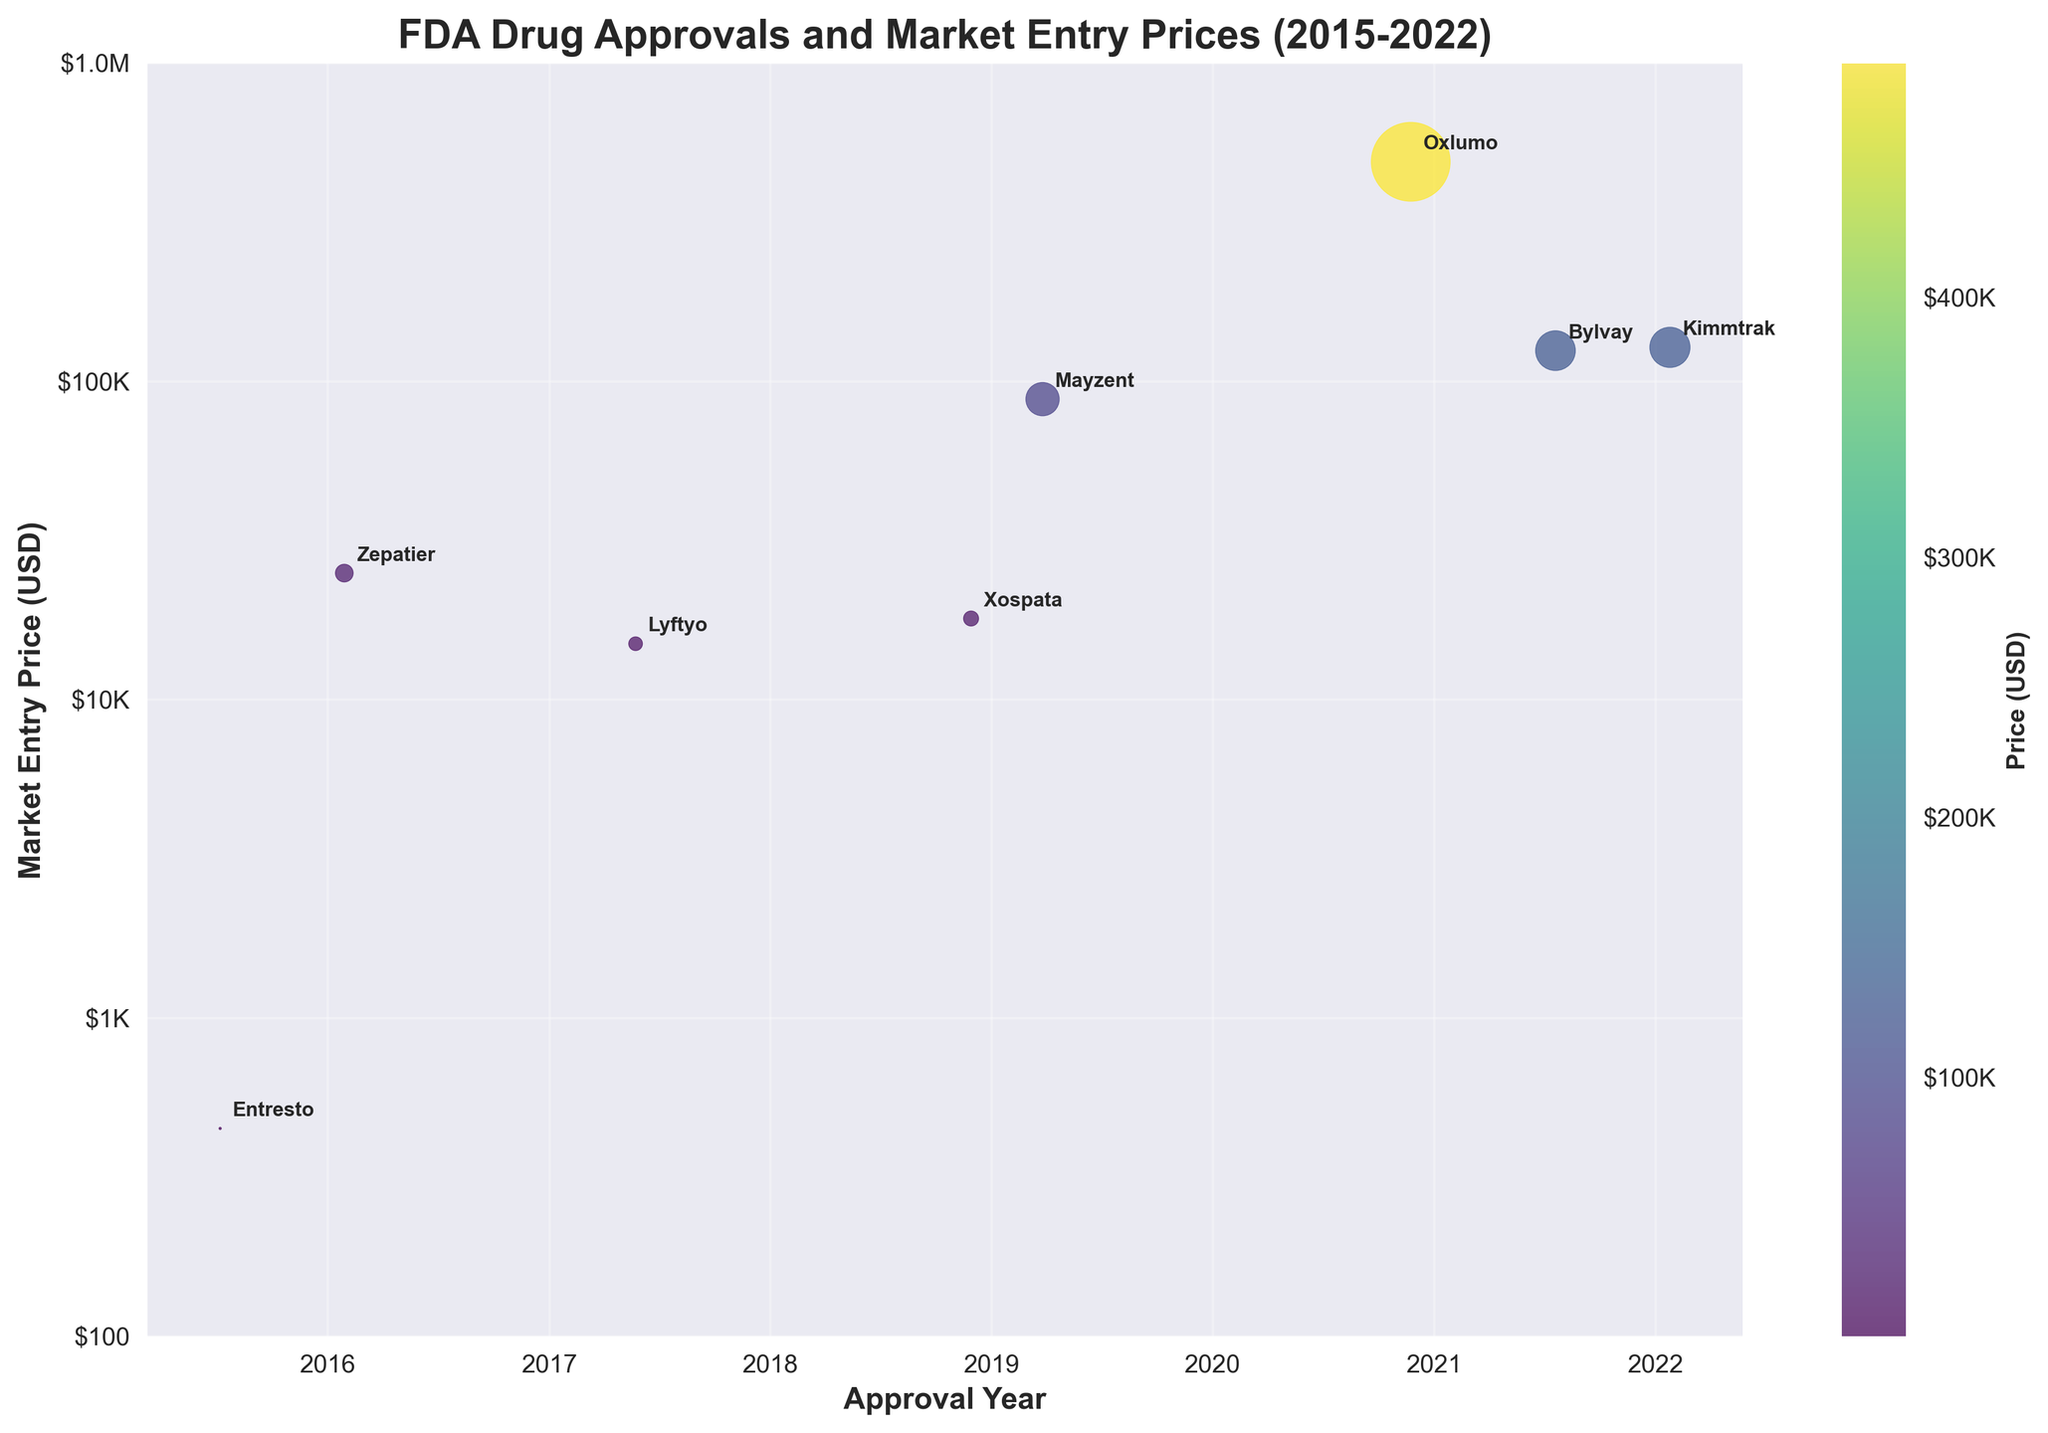What is the title of the figure? The title is clearly labeled at the top of the figure in bold text.
Answer: FDA Drug Approvals and Market Entry Prices (2015-2022) What does the x-axis represent? The x-axis shows years, and this can be identified by the labels and markings from 2015 to 2022.
Answer: Approval Year How does the market entry price of Mayzent compare to that of Oxlumo? First, locate the points representing Mayzent and Oxlumo based on their names next to their respective points. Then, compare their y-axis positions. Mayzent's price is $88,000, which is significantly lower than Oxlumo's $490,000.
Answer: Oxlumo is higher Which drug has the lowest market entry price and in what year was it approved? Identify the lowest point on the y-axis and check the label next to it, which is Zepatier, approved in 2016 with a price of $25,000.
Answer: Zepatier, 2016 What's the average market entry price of the drugs approved in 2017 and later? Identify the drugs approved in 2017 and later: Lyftyo, Xospata, Mayzent, Oxlumo, Bylvay, Kimmtrak. Sum their market prices: $15,000 + $18,000 + $88,000 + $490,000 + $125,000 + $128,000 = $864,000. Divide by the number of drugs (6): $864,000 / 6 = $144,000.
Answer: $144,000 What is the trend in drug market entry prices from 2015 to 2022? Observe the figure from left to right along the x-axis and note that the y-axis positions generally increase. This indicates a trend of increasing market entry prices over time.
Answer: Increasing trend Which drug has the highest market entry price and who is the manufacturer? Identify the highest point on the y-axis and check the label next to it, which is Oxlumo by Alnylam Pharmaceuticals.
Answer: Oxlumo, Alnylam Pharmaceuticals Are there more drugs approved by Novartis or Merck during this period? Locate the drugs by checking the manufacturer labels next to each drug name. Novartis has two drugs (Entresto, Mayzent), and Merck has one drug (Zepatier).
Answer: Novartis 